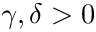Convert formula to latex. <formula><loc_0><loc_0><loc_500><loc_500>\gamma , \delta > 0</formula> 